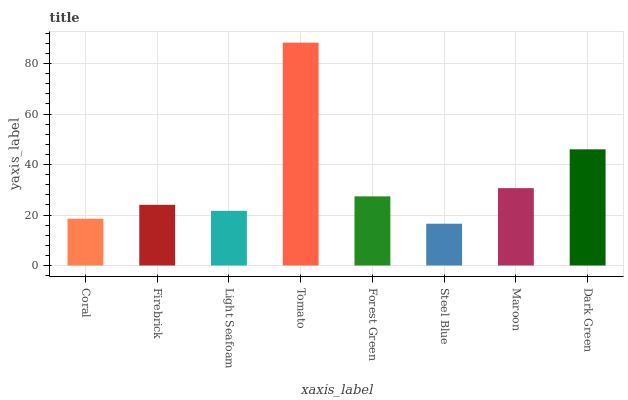Is Steel Blue the minimum?
Answer yes or no. Yes. Is Tomato the maximum?
Answer yes or no. Yes. Is Firebrick the minimum?
Answer yes or no. No. Is Firebrick the maximum?
Answer yes or no. No. Is Firebrick greater than Coral?
Answer yes or no. Yes. Is Coral less than Firebrick?
Answer yes or no. Yes. Is Coral greater than Firebrick?
Answer yes or no. No. Is Firebrick less than Coral?
Answer yes or no. No. Is Forest Green the high median?
Answer yes or no. Yes. Is Firebrick the low median?
Answer yes or no. Yes. Is Light Seafoam the high median?
Answer yes or no. No. Is Forest Green the low median?
Answer yes or no. No. 